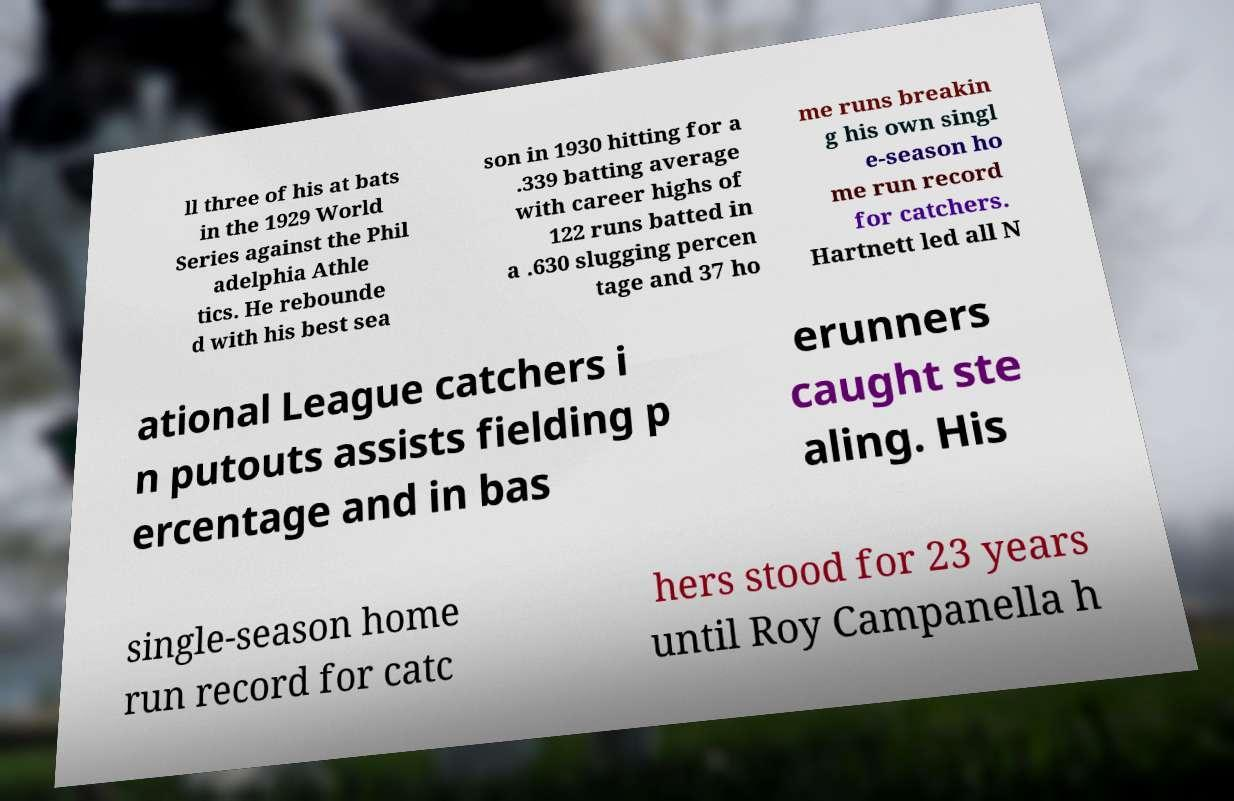Could you assist in decoding the text presented in this image and type it out clearly? ll three of his at bats in the 1929 World Series against the Phil adelphia Athle tics. He rebounde d with his best sea son in 1930 hitting for a .339 batting average with career highs of 122 runs batted in a .630 slugging percen tage and 37 ho me runs breakin g his own singl e-season ho me run record for catchers. Hartnett led all N ational League catchers i n putouts assists fielding p ercentage and in bas erunners caught ste aling. His single-season home run record for catc hers stood for 23 years until Roy Campanella h 